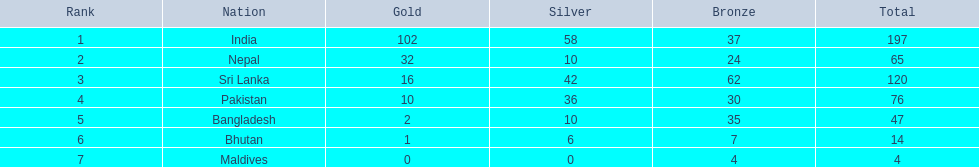In the table, which countries are listed? India, Nepal, Sri Lanka, Pakistan, Bangladesh, Bhutan, Maldives. Which one doesn't refer to india? Nepal, Sri Lanka, Pakistan, Bangladesh, Bhutan, Maldives. Which one is the first among them? Nepal. Parse the table in full. {'header': ['Rank', 'Nation', 'Gold', 'Silver', 'Bronze', 'Total'], 'rows': [['1', 'India', '102', '58', '37', '197'], ['2', 'Nepal', '32', '10', '24', '65'], ['3', 'Sri Lanka', '16', '42', '62', '120'], ['4', 'Pakistan', '10', '36', '30', '76'], ['5', 'Bangladesh', '2', '10', '35', '47'], ['6', 'Bhutan', '1', '6', '7', '14'], ['7', 'Maldives', '0', '0', '4', '4']]} 